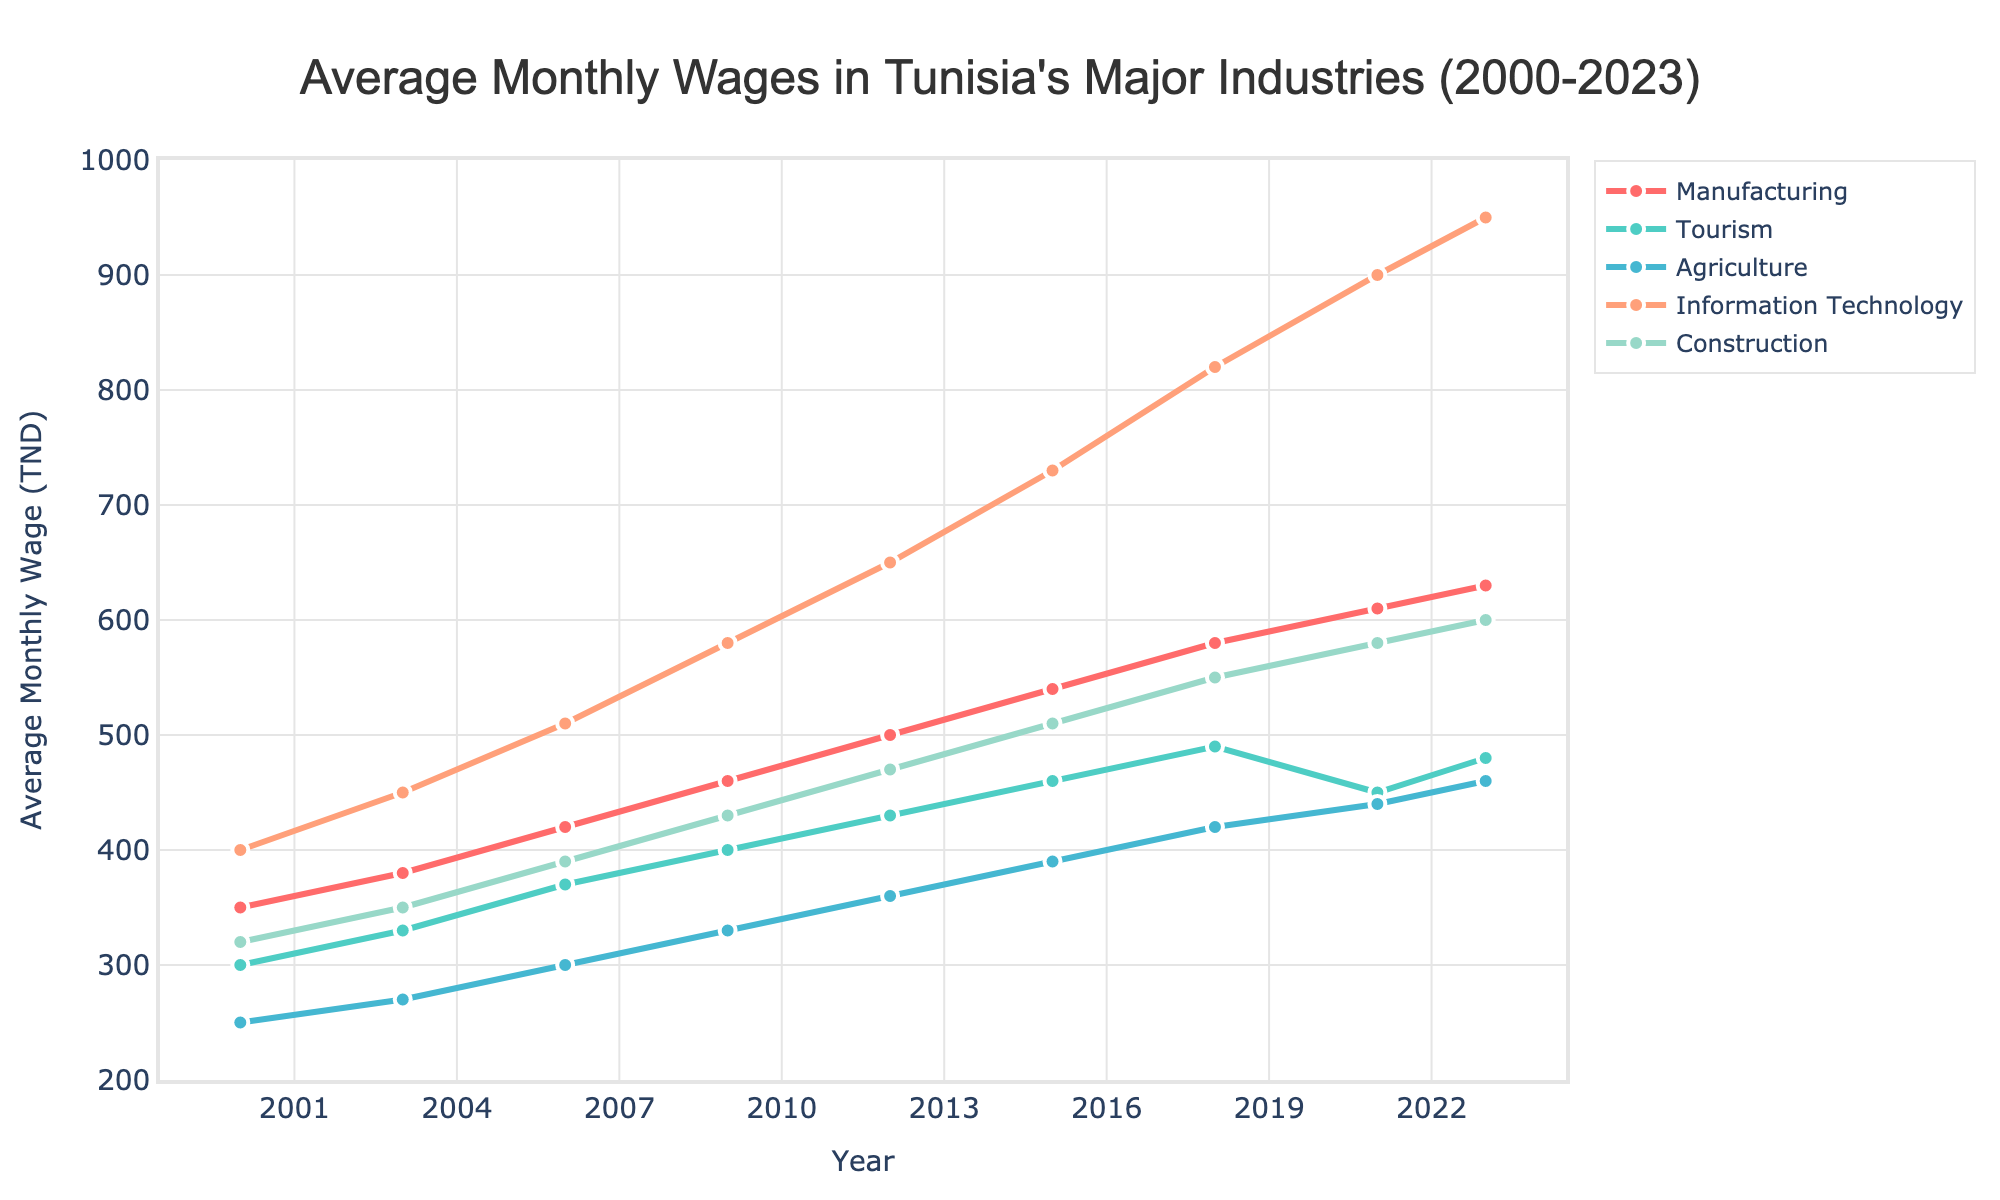What year did the Information Technology industry first surpass an average monthly wage of 500 TND? By looking at the Information Technology line (blue) on the chart and identifying the year it first crosses the 500 TND mark, we see it happens between 2006 and 2009. Thus, this occurred in 2009.
Answer: 2009 What is the difference in average monthly wages between the Tourism and Construction industries in 2012? First, identify the values for Tourism and Construction in 2012 from their respective lines. The average wage for Tourism is 430 TND, and for Construction, it is 470 TND. The difference is 470 - 430 = 40 TND.
Answer: 40 TND Which industry had the lowest average monthly wage in 2021? Looking at the graph's values for 2021, the lowest point belongs to the Tourism industry, with an average monthly wage of 450 TND.
Answer: Tourism Did any industry see a decrease in average monthly wages between any two consecutive years on the graph? Observing all lines on the graph, the Tourism industry experienced a drop from 490 TND in 2018 to 450 TND in 2021. No other industries show a decrease between consecutive years.
Answer: Yes, Tourism What is the average monthly wage for the Information Technology industry in 2023, and how does it compare to the Manufacturing industry in the same year? From the graph, the Information Technology wage in 2023 is 950 TND. The Manufacturing wage in 2023 is 630 TND. The IT wage surpasses the Manufacturing wage by 950 - 630 = 320 TND.
Answer: 950 TND; it is 320 TND higher than Manufacturing In which years did the Agriculture industry have an average monthly wage below 300 TND? From the graph, in 2000 (250 TND) and 2003 (270 TND), the Agriculture industry's average monthly wage was below 300 TND.
Answer: 2000 and 2003 Which industry showed the highest increase in average monthly wages from 2000 to 2023? Calculate the difference for each industry from 2000 to 2023 and compare. Information Technology increased from 400 to 950 TND (550 TND increase), making it the largest increase among the industries.
Answer: Information Technology By how much did the average monthly wage in Agriculture increase from 2000 to 2023? The Agriculture wages in 2000 were 250 TND, and in 2023 it is 460 TND. The increase is 460 - 250 = 210 TND.
Answer: 210 TND Which two industries had nearly the same average monthly wage in 2018? In 2018, both the Tourism (490 TND) and Construction (550 TND) at first look close; however, the closest match is Agriculture and Tourism both at around 490 TND.
Answer: Tourism and Agriculture 